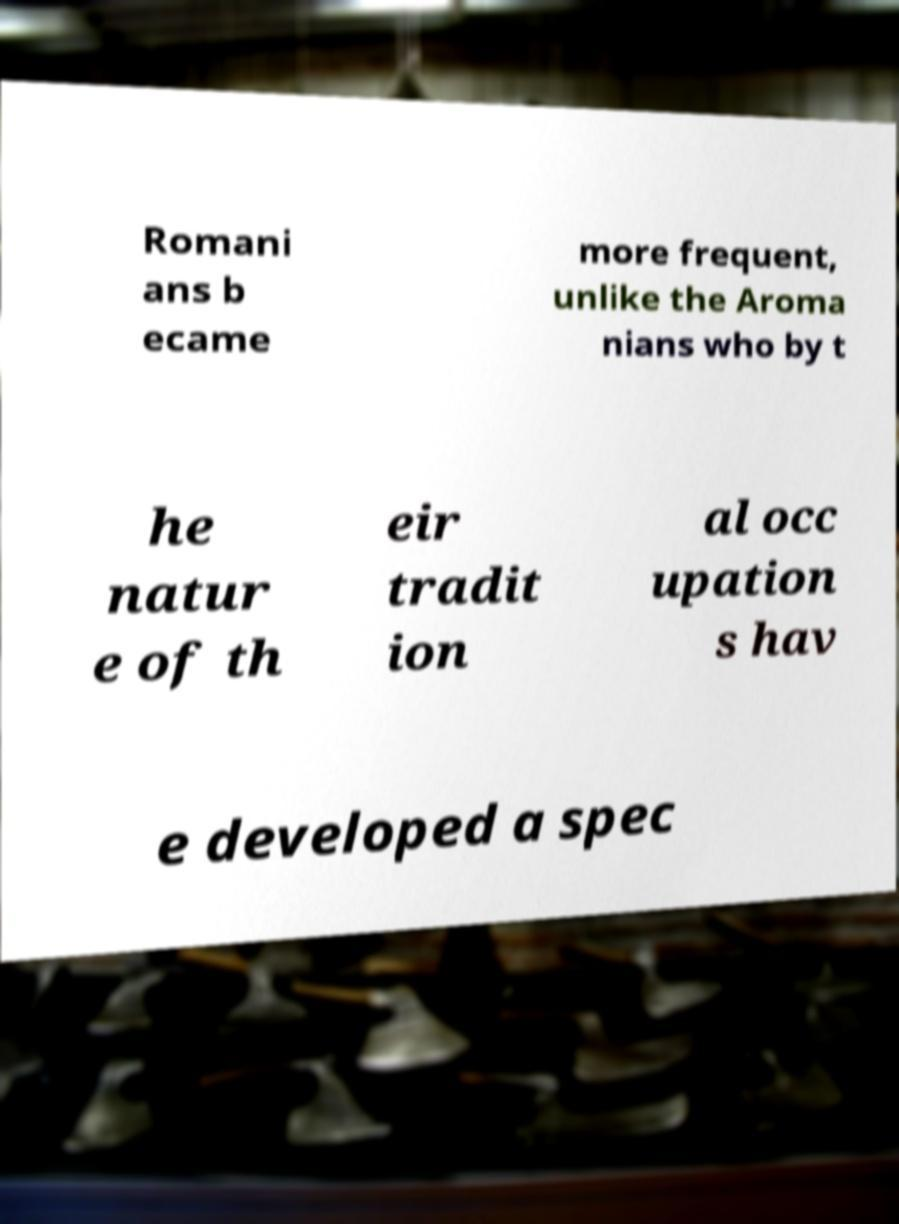Please read and relay the text visible in this image. What does it say? Romani ans b ecame more frequent, unlike the Aroma nians who by t he natur e of th eir tradit ion al occ upation s hav e developed a spec 